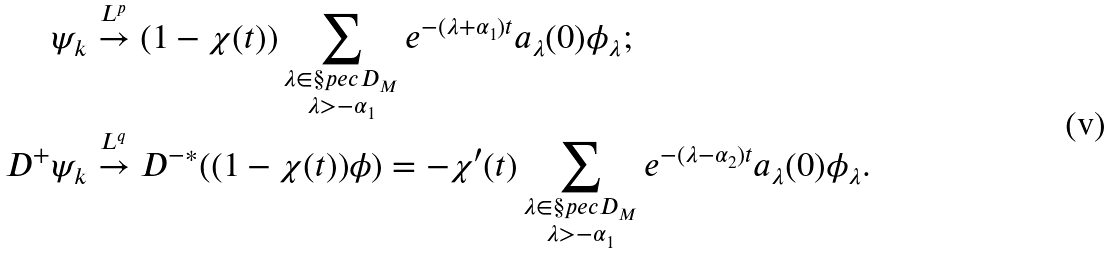<formula> <loc_0><loc_0><loc_500><loc_500>\psi _ { k } & \stackrel { L ^ { p } } { \to } ( 1 - \chi ( t ) ) \sum _ { \substack { \lambda \in \S p e c D _ { M } \\ \lambda > - \alpha _ { 1 } } } e ^ { - ( \lambda + \alpha _ { 1 } ) t } a _ { \lambda } ( 0 ) \phi _ { \lambda } ; \\ D ^ { + } \psi _ { k } & \stackrel { L ^ { q } } { \to } { D ^ { - } } ^ { * } ( ( 1 - \chi ( t ) ) \phi ) = - \chi ^ { \prime } ( t ) \sum _ { \substack { \lambda \in \S p e c D _ { M } \\ \lambda > - \alpha _ { 1 } } } e ^ { - ( \lambda - \alpha _ { 2 } ) t } a _ { \lambda } ( 0 ) \phi _ { \lambda } .</formula> 